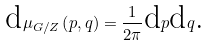Convert formula to latex. <formula><loc_0><loc_0><loc_500><loc_500>\text {d} \mu _ { G / Z } \left ( p , q \right ) = \frac { 1 } { 2 \pi } \text {d} p \text {d} q \text {.}</formula> 